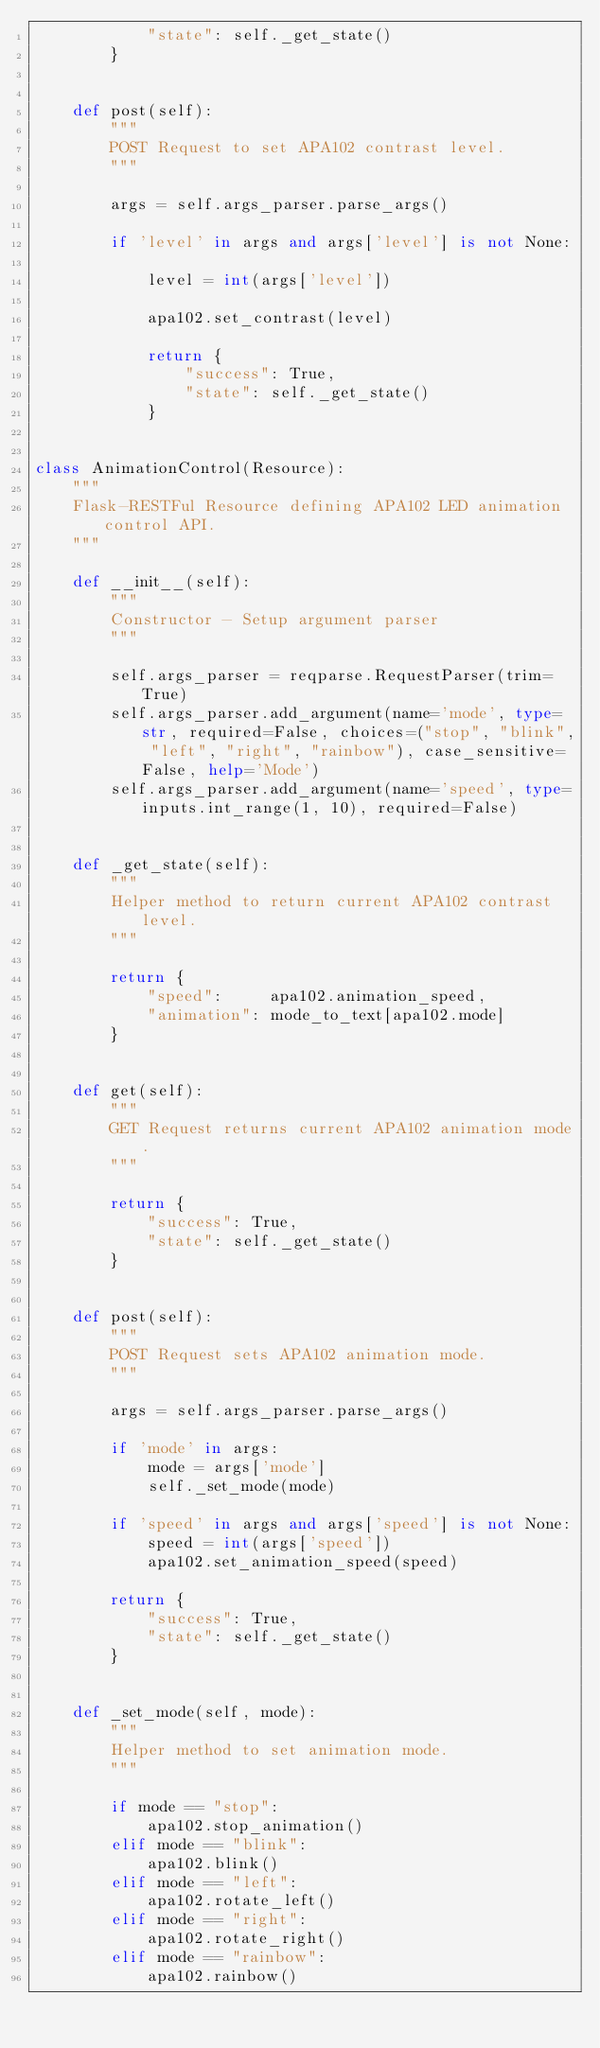Convert code to text. <code><loc_0><loc_0><loc_500><loc_500><_Python_>            "state": self._get_state()
        }


    def post(self):
        """
        POST Request to set APA102 contrast level.
        """

        args = self.args_parser.parse_args()

        if 'level' in args and args['level'] is not None:

            level = int(args['level'])

            apa102.set_contrast(level)

            return {
                "success": True,
                "state": self._get_state()
            }


class AnimationControl(Resource):
    """
    Flask-RESTFul Resource defining APA102 LED animation control API.
    """

    def __init__(self):
        """
        Constructor - Setup argument parser
        """

        self.args_parser = reqparse.RequestParser(trim=True)
        self.args_parser.add_argument(name='mode', type=str, required=False, choices=("stop", "blink", "left", "right", "rainbow"), case_sensitive=False, help='Mode')
        self.args_parser.add_argument(name='speed', type=inputs.int_range(1, 10), required=False)


    def _get_state(self):
        """
        Helper method to return current APA102 contrast level.
        """

        return {
            "speed":     apa102.animation_speed,
            "animation": mode_to_text[apa102.mode]
        }


    def get(self):
        """
        GET Request returns current APA102 animation mode.
        """

        return {
            "success": True,
            "state": self._get_state()
        }


    def post(self):
        """
        POST Request sets APA102 animation mode.
        """

        args = self.args_parser.parse_args()

        if 'mode' in args:
            mode = args['mode']
            self._set_mode(mode)

        if 'speed' in args and args['speed'] is not None:
            speed = int(args['speed'])
            apa102.set_animation_speed(speed)

        return {
            "success": True,
            "state": self._get_state()
        }


    def _set_mode(self, mode):
        """
        Helper method to set animation mode.
        """

        if mode == "stop":
            apa102.stop_animation()
        elif mode == "blink":
            apa102.blink()
        elif mode == "left":
            apa102.rotate_left()
        elif mode == "right":
            apa102.rotate_right()
        elif mode == "rainbow":
            apa102.rainbow()
</code> 